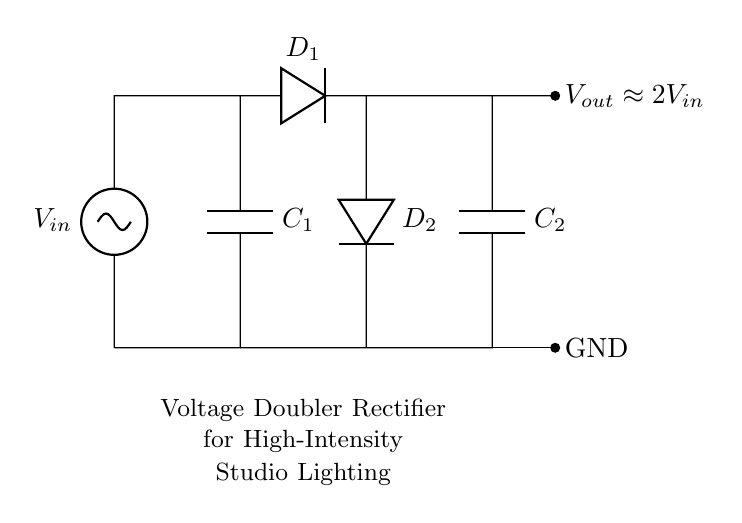What are the two types of components used in this circuit? The circuit features capacitors and diodes, specifically labeled as C1, C2 for capacitors and D1, D2 for diodes.
Answer: capacitors and diodes What is the purpose of the diodes in this circuit? The diodes D1 and D2 allow current to flow in one direction, thereby facilitating the rectification process, which converts AC voltage to DC voltage.
Answer: rectify the voltage What is the output voltage compared to the input voltage? The label indicates that the output voltage Vout is approximately twice the input voltage Vin, owing to the voltage doubler configuration.
Answer: approximately two times How many capacitors are present in this circuit? There are two capacitors, C1 and C2, connected in the voltage doubler configuration.
Answer: two What happens to the voltage after passing through the capacitors? The capacitors charge up to the peak voltage and provide a higher voltage at Vout compared to Vin, functioning as storage elements in the circuit.
Answer: it doubles What type of rectification does this circuit use? This circuit is configured as a voltage doubler rectifier, which is a specific arrangement that increases the output voltage.
Answer: voltage doubler 